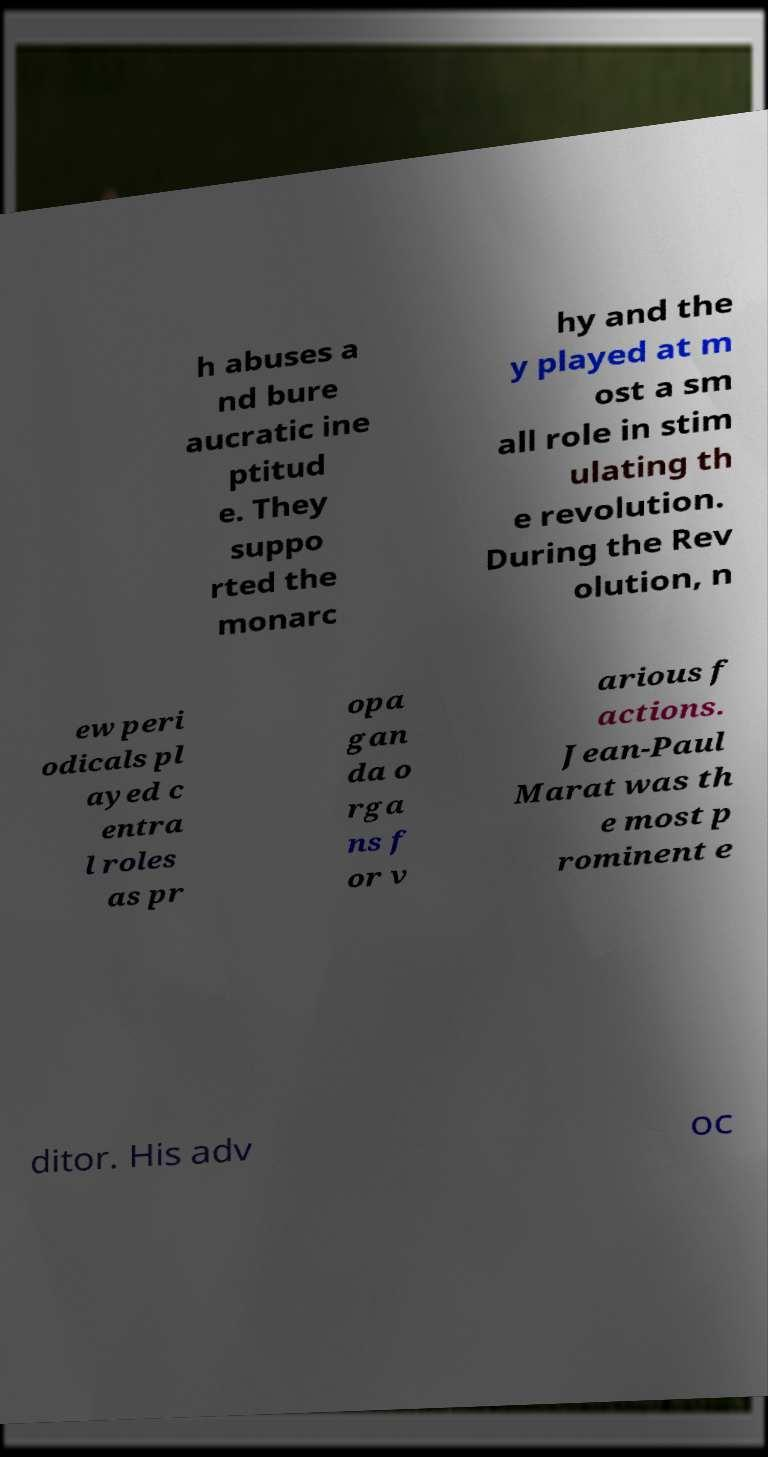Can you read and provide the text displayed in the image?This photo seems to have some interesting text. Can you extract and type it out for me? h abuses a nd bure aucratic ine ptitud e. They suppo rted the monarc hy and the y played at m ost a sm all role in stim ulating th e revolution. During the Rev olution, n ew peri odicals pl ayed c entra l roles as pr opa gan da o rga ns f or v arious f actions. Jean-Paul Marat was th e most p rominent e ditor. His adv oc 